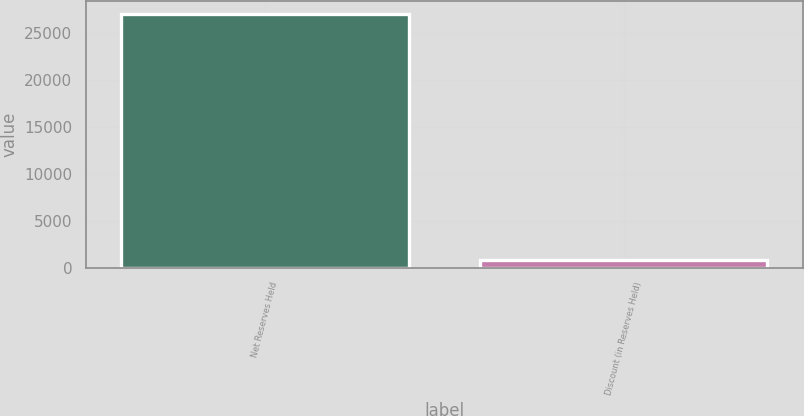Convert chart to OTSL. <chart><loc_0><loc_0><loc_500><loc_500><bar_chart><fcel>Net Reserves Held<fcel>Discount (in Reserves Held)<nl><fcel>27009.4<fcel>897<nl></chart> 